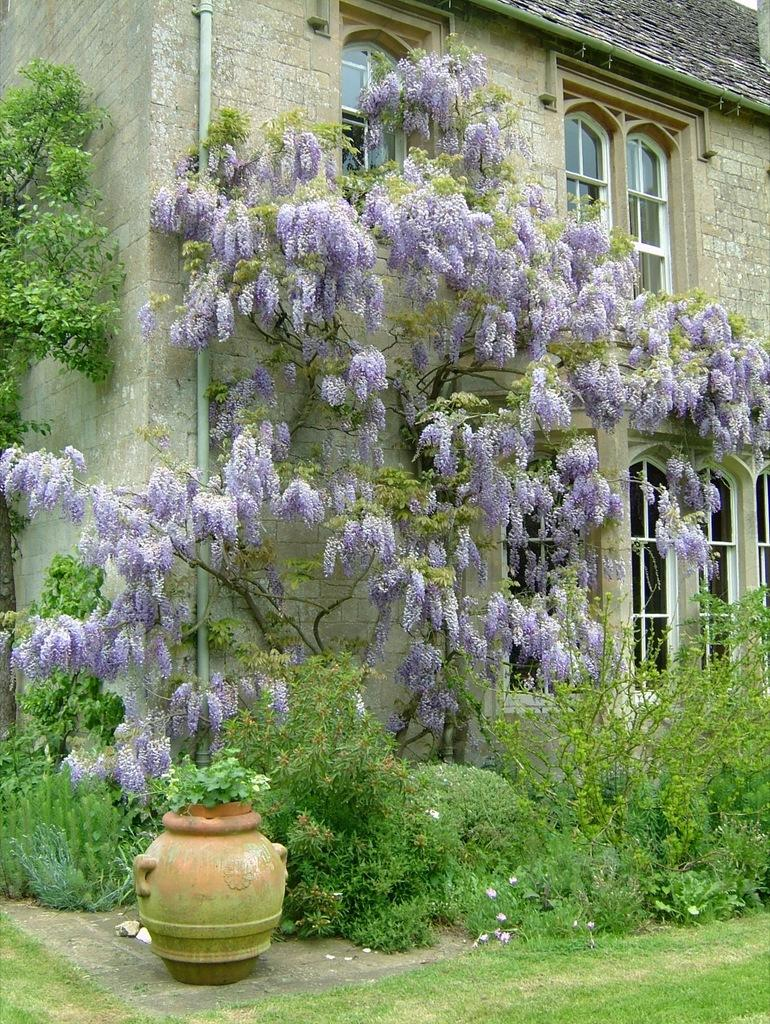What can be seen in the foreground of the image? There are plants and flowers, as well as a flower pot, in the foreground of the image. What type of vegetation is visible at the bottom of the image? There is grass at the bottom of the image. What structures can be seen in the background of the image? There is a house and a pipe in the background of the image. Are there any openings in the house visible in the image? Yes, there are windows in the background of the image. What grade is the house in the image? The image does not provide information about the grade of the house. How does the image capture the attention of the viewer? The image captures the attention of the viewer through the combination of plants, flowers, and the house in the background. 